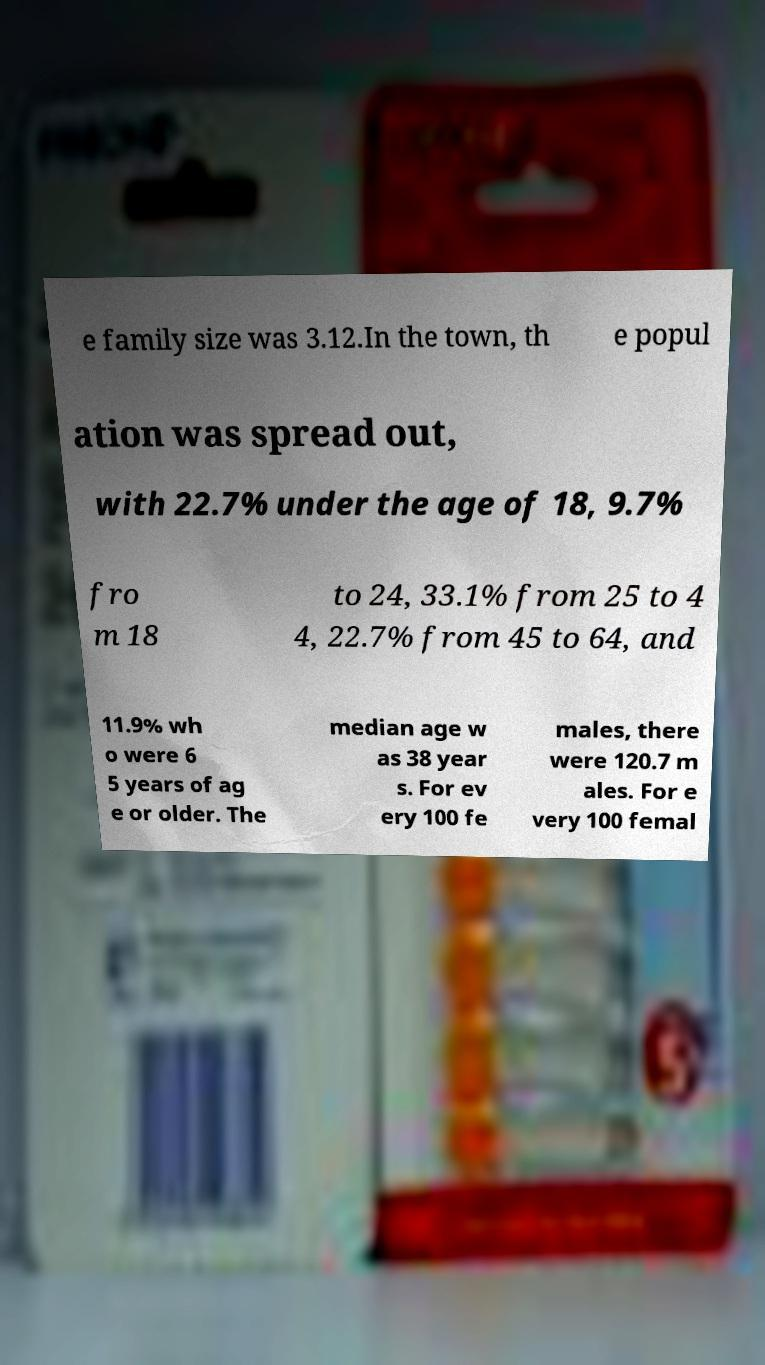Please read and relay the text visible in this image. What does it say? e family size was 3.12.In the town, th e popul ation was spread out, with 22.7% under the age of 18, 9.7% fro m 18 to 24, 33.1% from 25 to 4 4, 22.7% from 45 to 64, and 11.9% wh o were 6 5 years of ag e or older. The median age w as 38 year s. For ev ery 100 fe males, there were 120.7 m ales. For e very 100 femal 